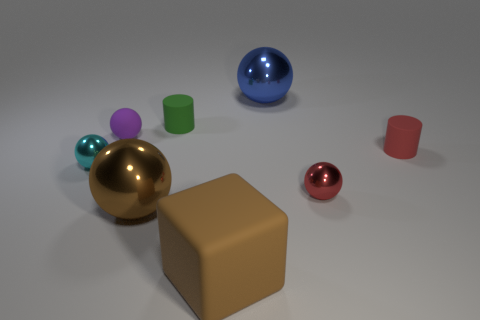Are there any other things that are the same shape as the brown matte object?
Your answer should be compact. No. There is a red ball that is the same size as the cyan object; what is its material?
Give a very brief answer. Metal. How many large objects are either red rubber cylinders or cyan things?
Offer a very short reply. 0. Do the big blue metal object and the small purple matte thing have the same shape?
Ensure brevity in your answer.  Yes. How many shiny balls are both on the left side of the block and right of the cyan shiny object?
Your answer should be very brief. 1. Is there anything else that has the same color as the rubber ball?
Provide a succinct answer. No. What is the shape of the large thing that is the same material as the green cylinder?
Your response must be concise. Cube. Is the brown sphere the same size as the red sphere?
Make the answer very short. No. Is the thing that is left of the purple rubber object made of the same material as the brown sphere?
Your response must be concise. Yes. There is a big thing that is left of the object in front of the large brown sphere; how many tiny purple matte spheres are in front of it?
Offer a terse response. 0. 